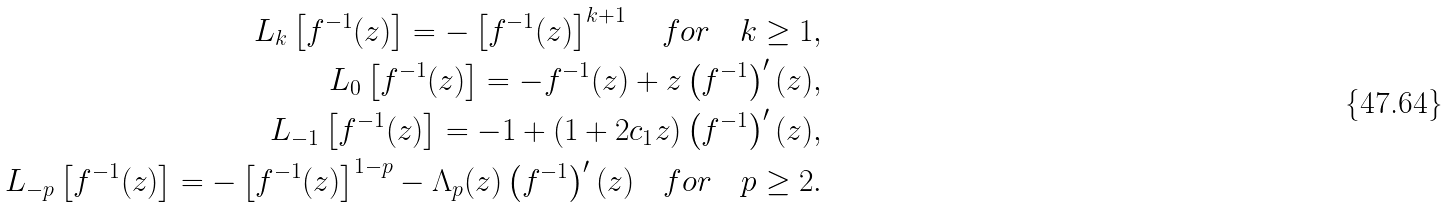<formula> <loc_0><loc_0><loc_500><loc_500>L _ { k } \left [ f ^ { - 1 } ( z ) \right ] = - \left [ f ^ { - 1 } ( z ) \right ] ^ { k + 1 } \quad f o r \quad k \geq 1 , \\ L _ { 0 } \left [ f ^ { - 1 } ( z ) \right ] = - f ^ { - 1 } ( z ) + z \left ( f ^ { - 1 } \right ) ^ { \prime } ( z ) , \\ L _ { - 1 } \left [ f ^ { - 1 } ( z ) \right ] = - 1 + ( 1 + 2 c _ { 1 } z ) \left ( f ^ { - 1 } \right ) ^ { \prime } ( z ) , \\ L _ { - p } \left [ f ^ { - 1 } ( z ) \right ] = - \left [ f ^ { - 1 } ( z ) \right ] ^ { 1 - p } - \Lambda _ { p } ( z ) \left ( f ^ { - 1 } \right ) ^ { \prime } ( z ) \quad f o r \quad p \geq 2 .</formula> 